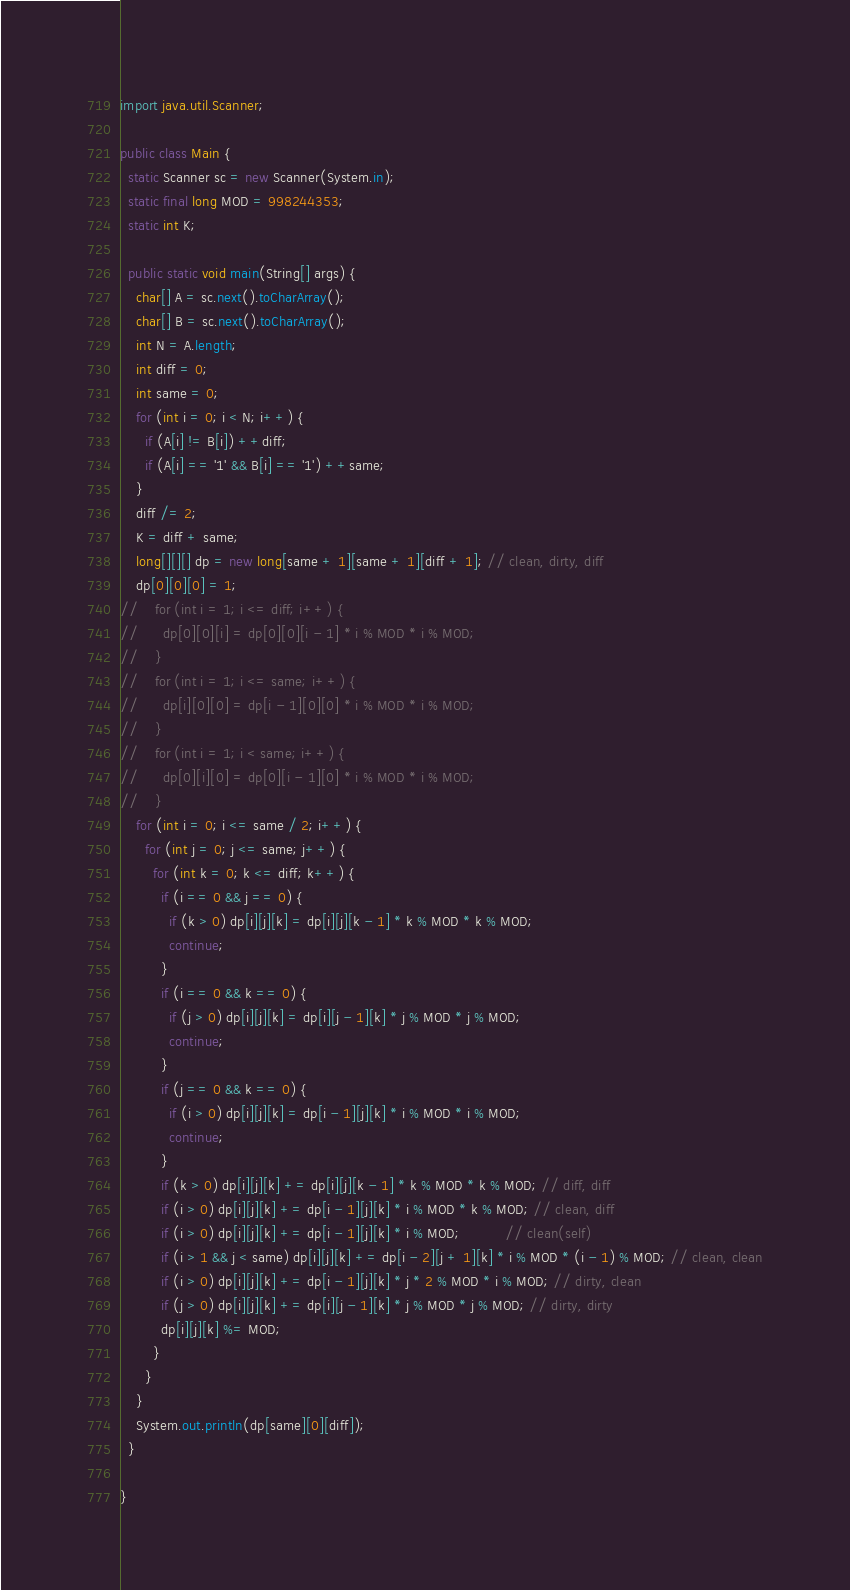<code> <loc_0><loc_0><loc_500><loc_500><_Java_>import java.util.Scanner;

public class Main {
  static Scanner sc = new Scanner(System.in);
  static final long MOD = 998244353;
  static int K;

  public static void main(String[] args) {
    char[] A = sc.next().toCharArray();
    char[] B = sc.next().toCharArray();
    int N = A.length;
    int diff = 0;
    int same = 0;
    for (int i = 0; i < N; i++) {
      if (A[i] != B[i]) ++diff;
      if (A[i] == '1' && B[i] == '1') ++same;
    }
    diff /= 2;
    K = diff + same;
    long[][][] dp = new long[same + 1][same + 1][diff + 1]; // clean, dirty, diff
    dp[0][0][0] = 1;
//    for (int i = 1; i <= diff; i++) {
//      dp[0][0][i] = dp[0][0][i - 1] * i % MOD * i % MOD;
//    }
//    for (int i = 1; i <= same; i++) {
//      dp[i][0][0] = dp[i - 1][0][0] * i % MOD * i % MOD;
//    }
//    for (int i = 1; i < same; i++) {
//      dp[0][i][0] = dp[0][i - 1][0] * i % MOD * i % MOD;
//    }
    for (int i = 0; i <= same / 2; i++) {
      for (int j = 0; j <= same; j++) {
        for (int k = 0; k <= diff; k++) {
          if (i == 0 && j == 0) {
            if (k > 0) dp[i][j][k] = dp[i][j][k - 1] * k % MOD * k % MOD;
            continue;
          }
          if (i == 0 && k == 0) {
            if (j > 0) dp[i][j][k] = dp[i][j - 1][k] * j % MOD * j % MOD;
            continue;
          }
          if (j == 0 && k == 0) {
            if (i > 0) dp[i][j][k] = dp[i - 1][j][k] * i % MOD * i % MOD;
            continue;
          }
          if (k > 0) dp[i][j][k] += dp[i][j][k - 1] * k % MOD * k % MOD; // diff, diff
          if (i > 0) dp[i][j][k] += dp[i - 1][j][k] * i % MOD * k % MOD; // clean, diff
          if (i > 0) dp[i][j][k] += dp[i - 1][j][k] * i % MOD;           // clean(self)
          if (i > 1 && j < same) dp[i][j][k] += dp[i - 2][j + 1][k] * i % MOD * (i - 1) % MOD; // clean, clean
          if (i > 0) dp[i][j][k] += dp[i - 1][j][k] * j * 2 % MOD * i % MOD; // dirty, clean
          if (j > 0) dp[i][j][k] += dp[i][j - 1][k] * j % MOD * j % MOD; // dirty, dirty
          dp[i][j][k] %= MOD;
        }
      }
    }
    System.out.println(dp[same][0][diff]);
  }

}
</code> 